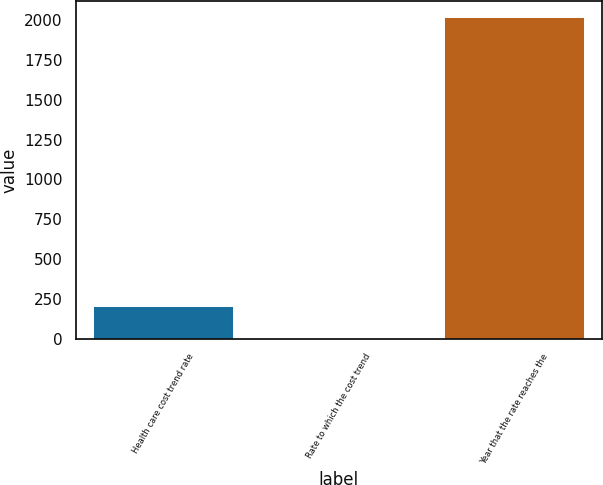Convert chart to OTSL. <chart><loc_0><loc_0><loc_500><loc_500><bar_chart><fcel>Health care cost trend rate<fcel>Rate to which the cost trend<fcel>Year that the rate reaches the<nl><fcel>206.58<fcel>5.2<fcel>2019<nl></chart> 